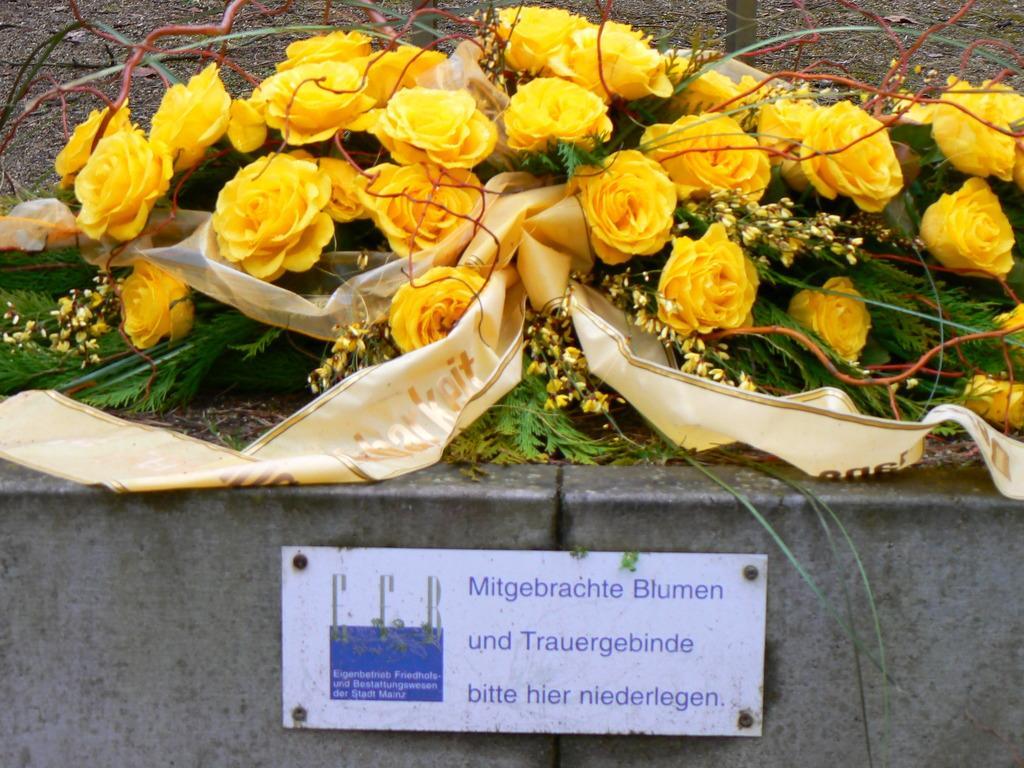How would you summarize this image in a sentence or two? In this picture we can see a name board on the wall and in the background we can see flowers, leaves. 